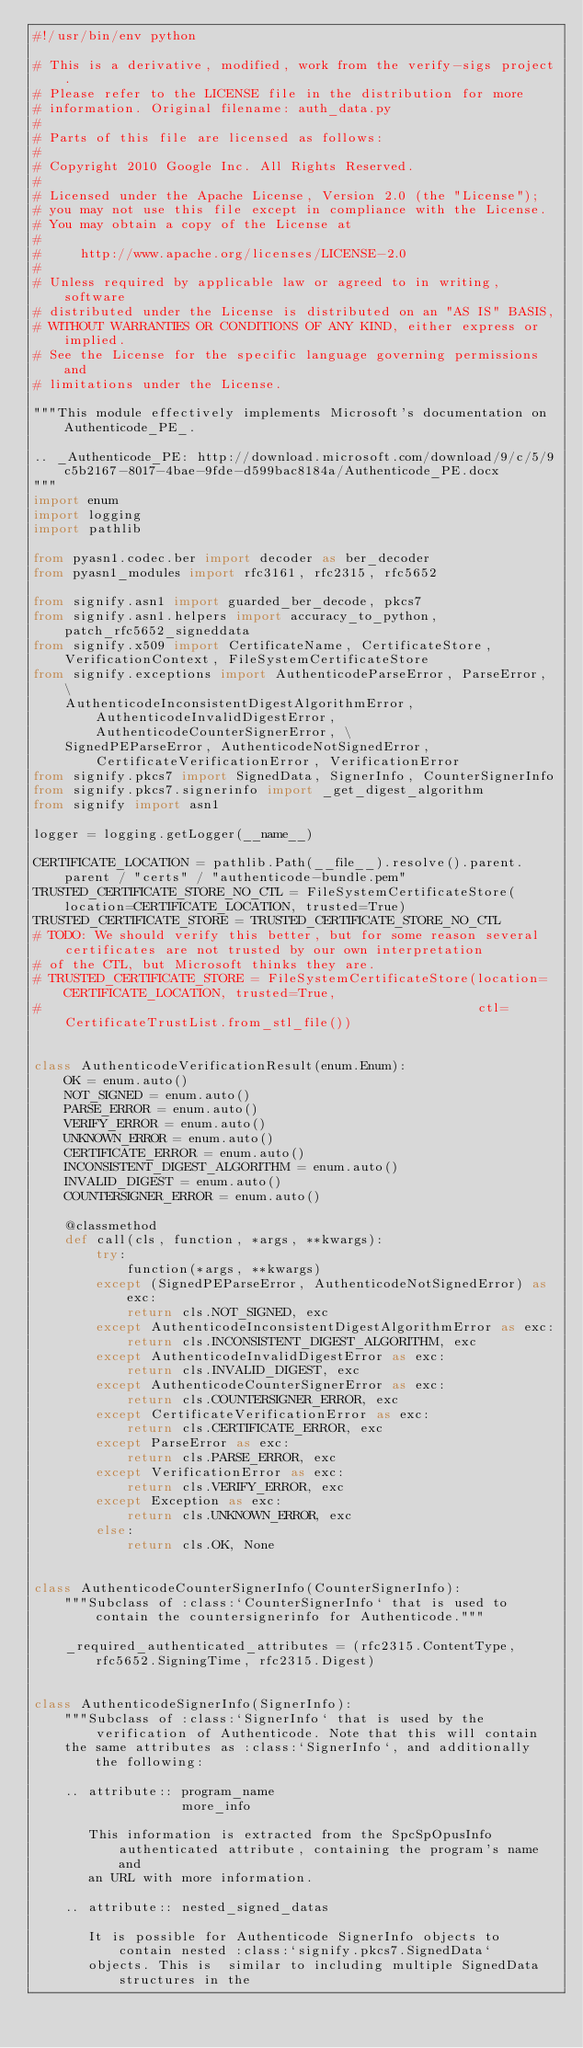<code> <loc_0><loc_0><loc_500><loc_500><_Python_>#!/usr/bin/env python

# This is a derivative, modified, work from the verify-sigs project.
# Please refer to the LICENSE file in the distribution for more
# information. Original filename: auth_data.py
#
# Parts of this file are licensed as follows:
#
# Copyright 2010 Google Inc. All Rights Reserved.
#
# Licensed under the Apache License, Version 2.0 (the "License");
# you may not use this file except in compliance with the License.
# You may obtain a copy of the License at
#
#     http://www.apache.org/licenses/LICENSE-2.0
#
# Unless required by applicable law or agreed to in writing, software
# distributed under the License is distributed on an "AS IS" BASIS,
# WITHOUT WARRANTIES OR CONDITIONS OF ANY KIND, either express or implied.
# See the License for the specific language governing permissions and
# limitations under the License.

"""This module effectively implements Microsoft's documentation on Authenticode_PE_.

.. _Authenticode_PE: http://download.microsoft.com/download/9/c/5/9c5b2167-8017-4bae-9fde-d599bac8184a/Authenticode_PE.docx
"""
import enum
import logging
import pathlib

from pyasn1.codec.ber import decoder as ber_decoder
from pyasn1_modules import rfc3161, rfc2315, rfc5652

from signify.asn1 import guarded_ber_decode, pkcs7
from signify.asn1.helpers import accuracy_to_python, patch_rfc5652_signeddata
from signify.x509 import CertificateName, CertificateStore, VerificationContext, FileSystemCertificateStore
from signify.exceptions import AuthenticodeParseError, ParseError, \
    AuthenticodeInconsistentDigestAlgorithmError, AuthenticodeInvalidDigestError, AuthenticodeCounterSignerError, \
    SignedPEParseError, AuthenticodeNotSignedError, CertificateVerificationError, VerificationError
from signify.pkcs7 import SignedData, SignerInfo, CounterSignerInfo
from signify.pkcs7.signerinfo import _get_digest_algorithm
from signify import asn1

logger = logging.getLogger(__name__)

CERTIFICATE_LOCATION = pathlib.Path(__file__).resolve().parent.parent / "certs" / "authenticode-bundle.pem"
TRUSTED_CERTIFICATE_STORE_NO_CTL = FileSystemCertificateStore(location=CERTIFICATE_LOCATION, trusted=True)
TRUSTED_CERTIFICATE_STORE = TRUSTED_CERTIFICATE_STORE_NO_CTL
# TODO: We should verify this better, but for some reason several certificates are not trusted by our own interpretation
# of the CTL, but Microsoft thinks they are.
# TRUSTED_CERTIFICATE_STORE = FileSystemCertificateStore(location=CERTIFICATE_LOCATION, trusted=True,
#                                                        ctl=CertificateTrustList.from_stl_file())


class AuthenticodeVerificationResult(enum.Enum):
    OK = enum.auto()
    NOT_SIGNED = enum.auto()
    PARSE_ERROR = enum.auto()
    VERIFY_ERROR = enum.auto()
    UNKNOWN_ERROR = enum.auto()
    CERTIFICATE_ERROR = enum.auto()
    INCONSISTENT_DIGEST_ALGORITHM = enum.auto()
    INVALID_DIGEST = enum.auto()
    COUNTERSIGNER_ERROR = enum.auto()

    @classmethod
    def call(cls, function, *args, **kwargs):
        try:
            function(*args, **kwargs)
        except (SignedPEParseError, AuthenticodeNotSignedError) as exc:
            return cls.NOT_SIGNED, exc
        except AuthenticodeInconsistentDigestAlgorithmError as exc:
            return cls.INCONSISTENT_DIGEST_ALGORITHM, exc
        except AuthenticodeInvalidDigestError as exc:
            return cls.INVALID_DIGEST, exc
        except AuthenticodeCounterSignerError as exc:
            return cls.COUNTERSIGNER_ERROR, exc
        except CertificateVerificationError as exc:
            return cls.CERTIFICATE_ERROR, exc
        except ParseError as exc:
            return cls.PARSE_ERROR, exc
        except VerificationError as exc:
            return cls.VERIFY_ERROR, exc
        except Exception as exc:
            return cls.UNKNOWN_ERROR, exc
        else:
            return cls.OK, None


class AuthenticodeCounterSignerInfo(CounterSignerInfo):
    """Subclass of :class:`CounterSignerInfo` that is used to contain the countersignerinfo for Authenticode."""

    _required_authenticated_attributes = (rfc2315.ContentType, rfc5652.SigningTime, rfc2315.Digest)


class AuthenticodeSignerInfo(SignerInfo):
    """Subclass of :class:`SignerInfo` that is used by the verification of Authenticode. Note that this will contain
    the same attributes as :class:`SignerInfo`, and additionally the following:

    .. attribute:: program_name
                   more_info

       This information is extracted from the SpcSpOpusInfo authenticated attribute, containing the program's name and
       an URL with more information.

    .. attribute:: nested_signed_datas

       It is possible for Authenticode SignerInfo objects to contain nested :class:`signify.pkcs7.SignedData`
       objects. This is  similar to including multiple SignedData structures in the</code> 